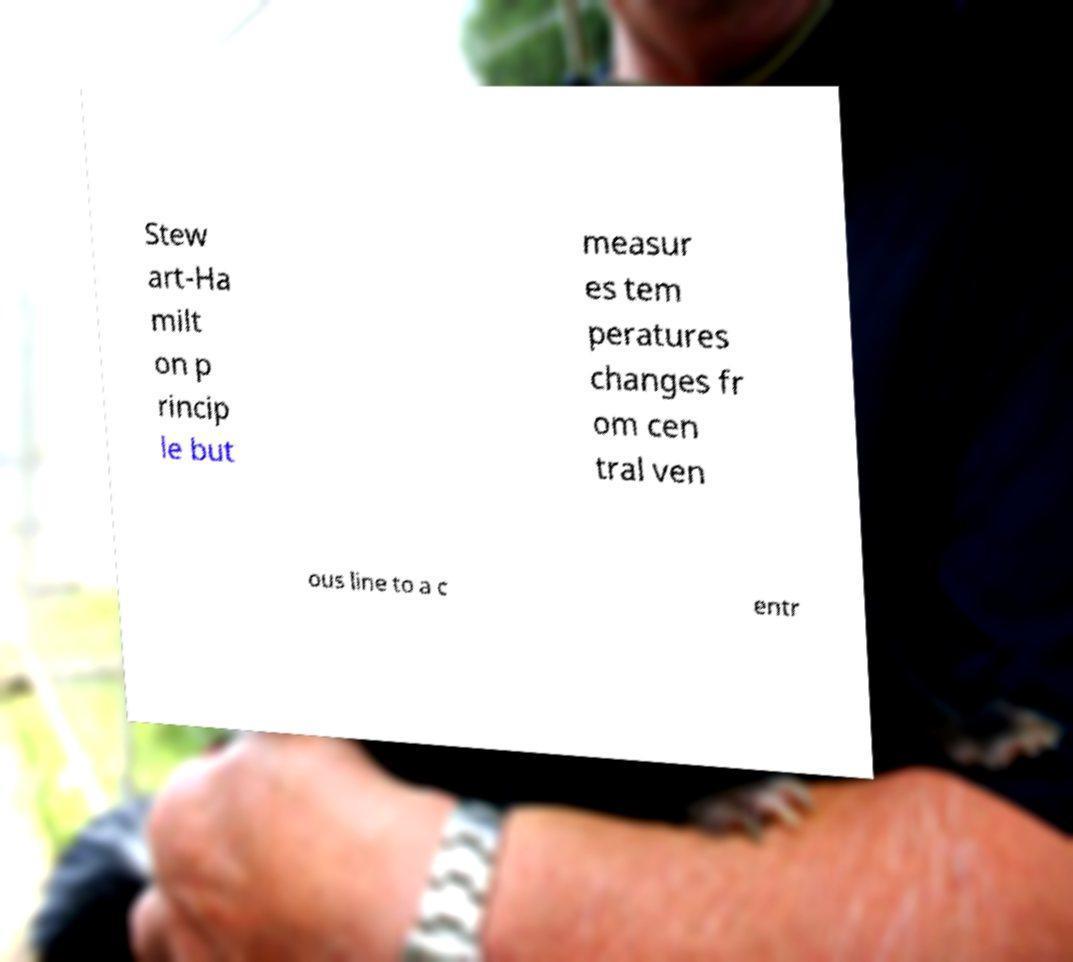Could you extract and type out the text from this image? Stew art-Ha milt on p rincip le but measur es tem peratures changes fr om cen tral ven ous line to a c entr 